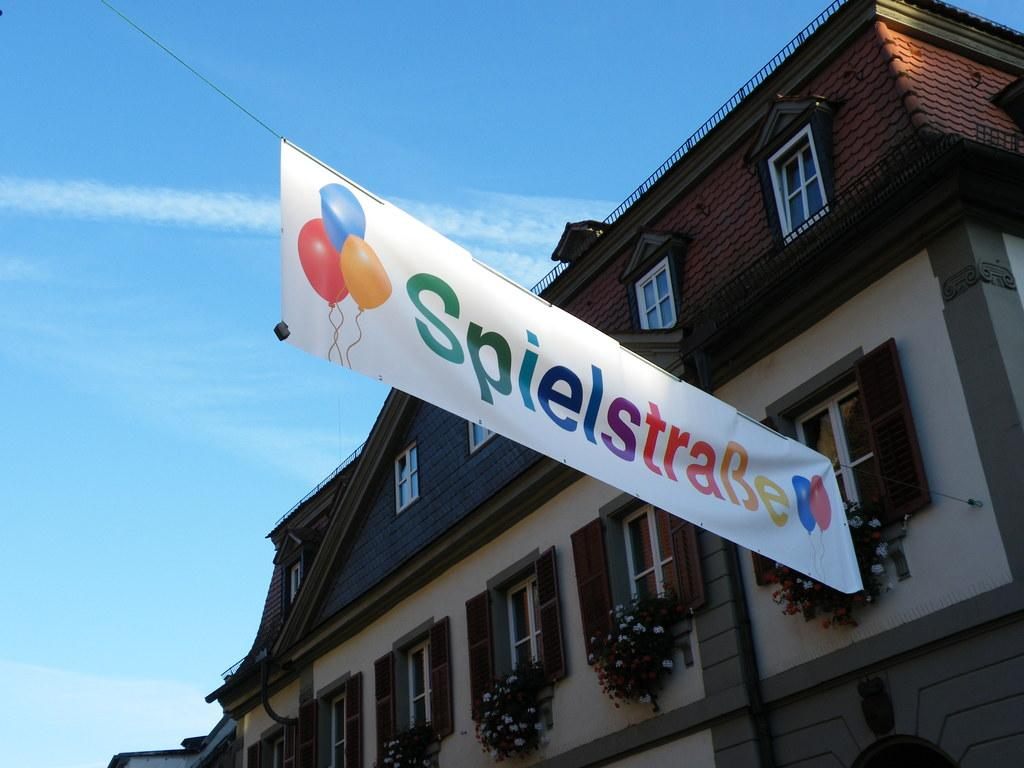What type of structure is visible in the image? There is a building in the image. What can be seen on the windows of the building? There are windows with flower pots in the image. What additional feature is present on the building? There is a banner in the image. How many pots can be seen in the eyes of the building in the image? There are no pots visible in the eyes of the building, as buildings do not have eyes. 